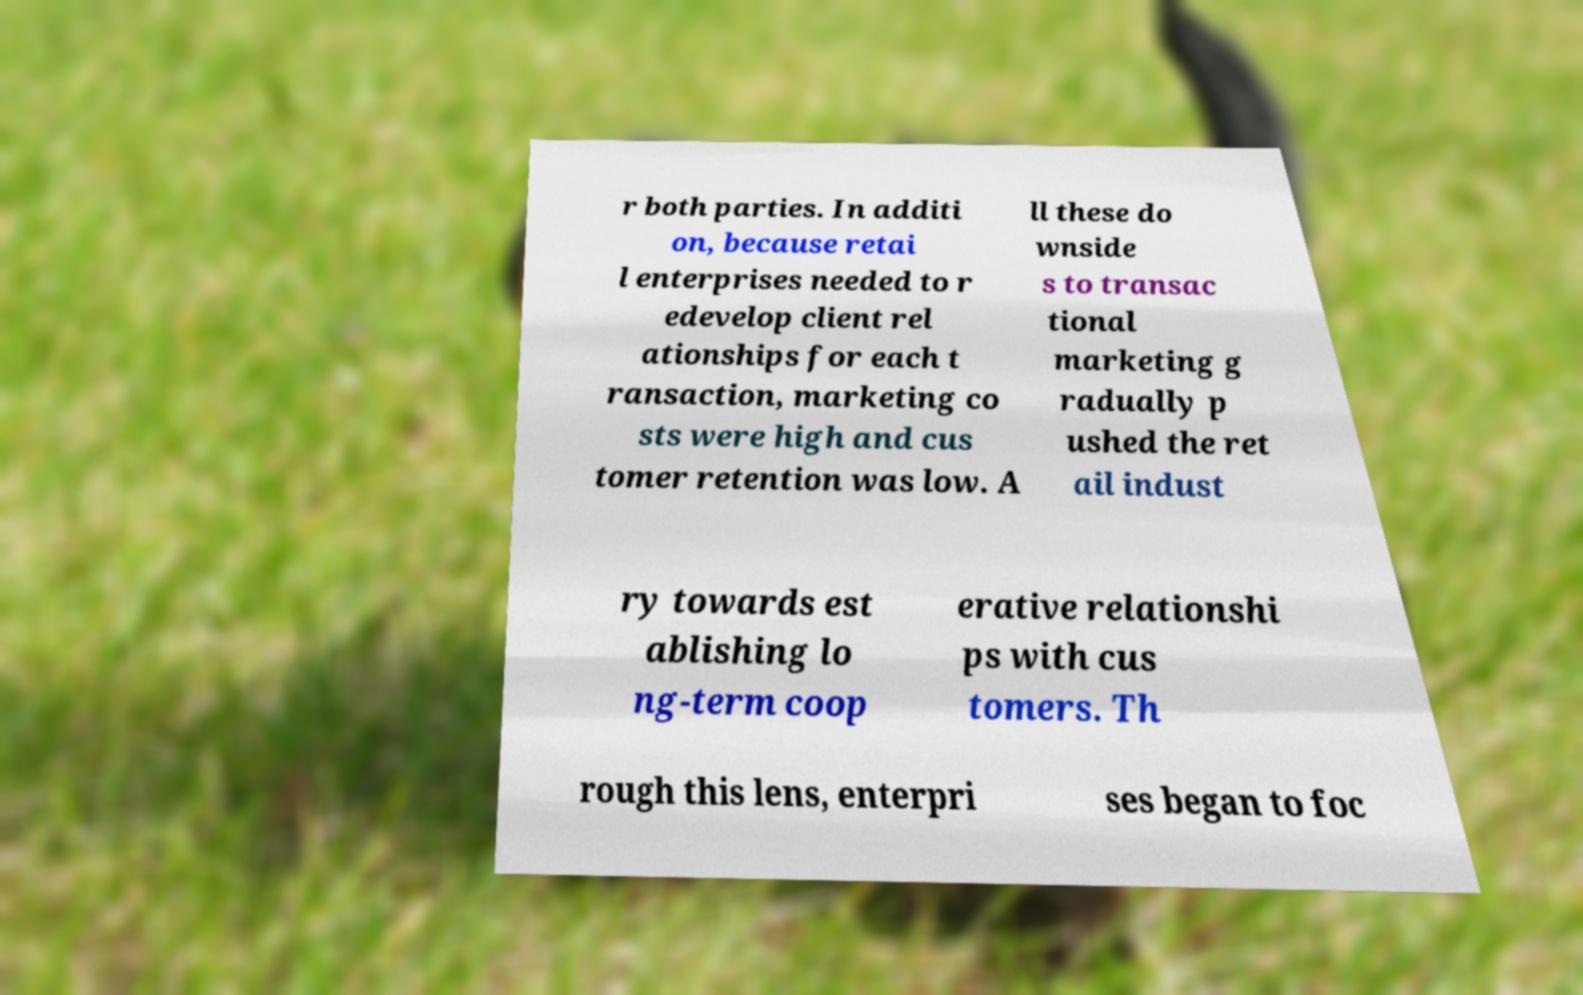I need the written content from this picture converted into text. Can you do that? r both parties. In additi on, because retai l enterprises needed to r edevelop client rel ationships for each t ransaction, marketing co sts were high and cus tomer retention was low. A ll these do wnside s to transac tional marketing g radually p ushed the ret ail indust ry towards est ablishing lo ng-term coop erative relationshi ps with cus tomers. Th rough this lens, enterpri ses began to foc 